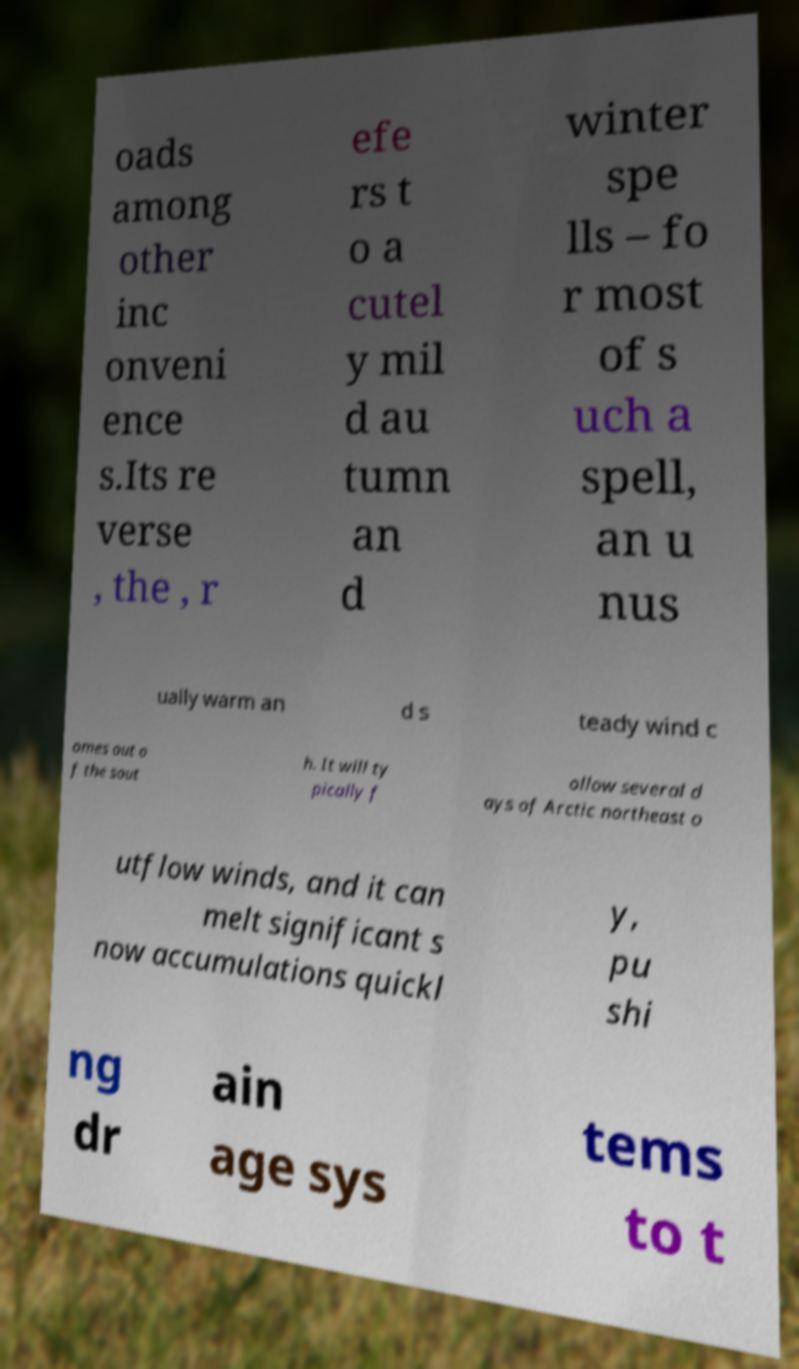Could you assist in decoding the text presented in this image and type it out clearly? oads among other inc onveni ence s.Its re verse , the , r efe rs t o a cutel y mil d au tumn an d winter spe lls – fo r most of s uch a spell, an u nus ually warm an d s teady wind c omes out o f the sout h. It will ty pically f ollow several d ays of Arctic northeast o utflow winds, and it can melt significant s now accumulations quickl y, pu shi ng dr ain age sys tems to t 